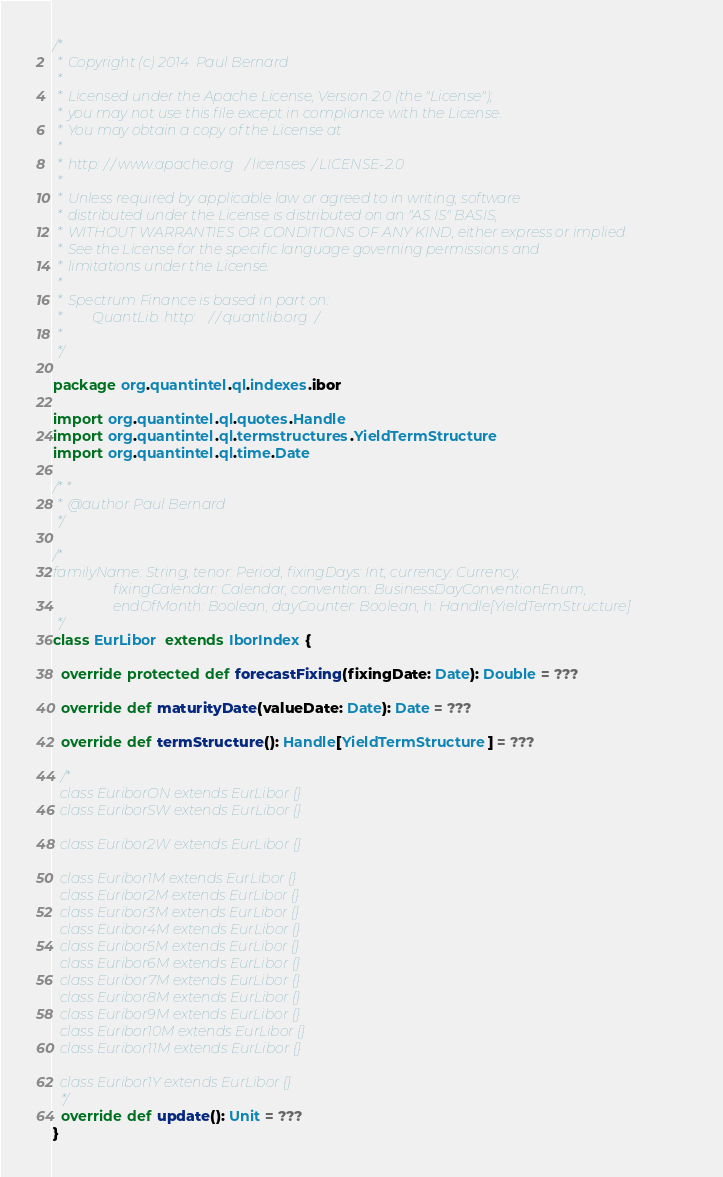Convert code to text. <code><loc_0><loc_0><loc_500><loc_500><_Scala_>/*
 * Copyright (c) 2014  Paul Bernard
 *
 * Licensed under the Apache License, Version 2.0 (the "License");
 * you may not use this file except in compliance with the License.
 * You may obtain a copy of the License at
 *
 * http://www.apache.org/licenses/LICENSE-2.0
 *
 * Unless required by applicable law or agreed to in writing, software
 * distributed under the License is distributed on an "AS IS" BASIS,
 * WITHOUT WARRANTIES OR CONDITIONS OF ANY KIND, either express or implied.
 * See the License for the specific language governing permissions and
 * limitations under the License.
 *
 * Spectrum Finance is based in part on:
 *        QuantLib. http://quantlib.org/
 *
 */

package org.quantintel.ql.indexes.ibor

import org.quantintel.ql.quotes.Handle
import org.quantintel.ql.termstructures.YieldTermStructure
import org.quantintel.ql.time.Date

/**
 * @author Paul Bernard
 */

/*
familyName: String, tenor: Period, fixingDays: Int, currency: Currency,
                 fixingCalendar: Calendar, convention: BusinessDayConventionEnum,
                 endOfMonth: Boolean, dayCounter: Boolean, h: Handle[YieldTermStructure]
 */
class EurLibor  extends IborIndex {

  override protected def forecastFixing(fixingDate: Date): Double = ???

  override def maturityDate(valueDate: Date): Date = ???

  override def termStructure(): Handle[YieldTermStructure] = ???

  /*
  class EuriborON extends EurLibor {}
  class EuriborSW extends EurLibor {}

  class Euribor2W extends EurLibor {}

  class Euribor1M extends EurLibor {}
  class Euribor2M extends EurLibor {}
  class Euribor3M extends EurLibor {}
  class Euribor4M extends EurLibor {}
  class Euribor5M extends EurLibor {}
  class Euribor6M extends EurLibor {}
  class Euribor7M extends EurLibor {}
  class Euribor8M extends EurLibor {}
  class Euribor9M extends EurLibor {}
  class Euribor10M extends EurLibor {}
  class Euribor11M extends EurLibor {}

  class Euribor1Y extends EurLibor {}
  */
  override def update(): Unit = ???
}
</code> 